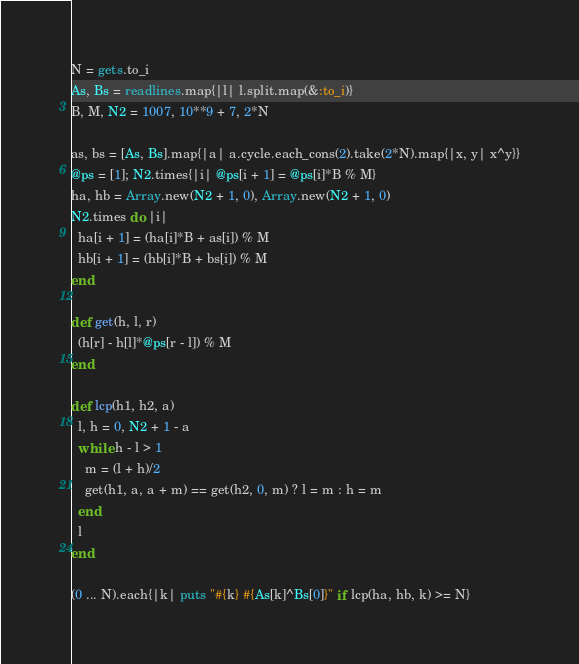Convert code to text. <code><loc_0><loc_0><loc_500><loc_500><_Ruby_>N = gets.to_i
As, Bs = readlines.map{|l| l.split.map(&:to_i)}
B, M, N2 = 1007, 10**9 + 7, 2*N

as, bs = [As, Bs].map{|a| a.cycle.each_cons(2).take(2*N).map{|x, y| x^y}}
@ps = [1]; N2.times{|i| @ps[i + 1] = @ps[i]*B % M}
ha, hb = Array.new(N2 + 1, 0), Array.new(N2 + 1, 0)
N2.times do |i|
  ha[i + 1] = (ha[i]*B + as[i]) % M
  hb[i + 1] = (hb[i]*B + bs[i]) % M
end

def get(h, l, r)
  (h[r] - h[l]*@ps[r - l]) % M
end

def lcp(h1, h2, a)
  l, h = 0, N2 + 1 - a
  while h - l > 1
    m = (l + h)/2
    get(h1, a, a + m) == get(h2, 0, m) ? l = m : h = m
  end
  l
end

(0 ... N).each{|k| puts "#{k} #{As[k]^Bs[0]}" if lcp(ha, hb, k) >= N}</code> 